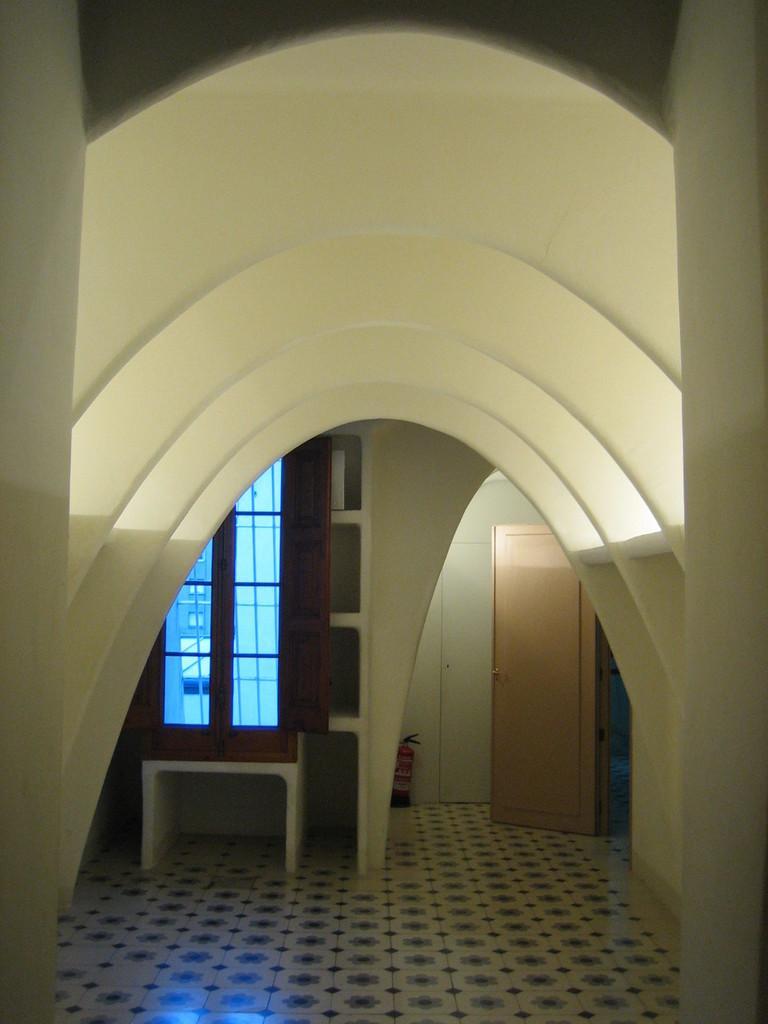Could you give a brief overview of what you see in this image? In the picture we can see a door, fire extinguisher, wall, window, glasses, and floor. From the glass we can see a building. 